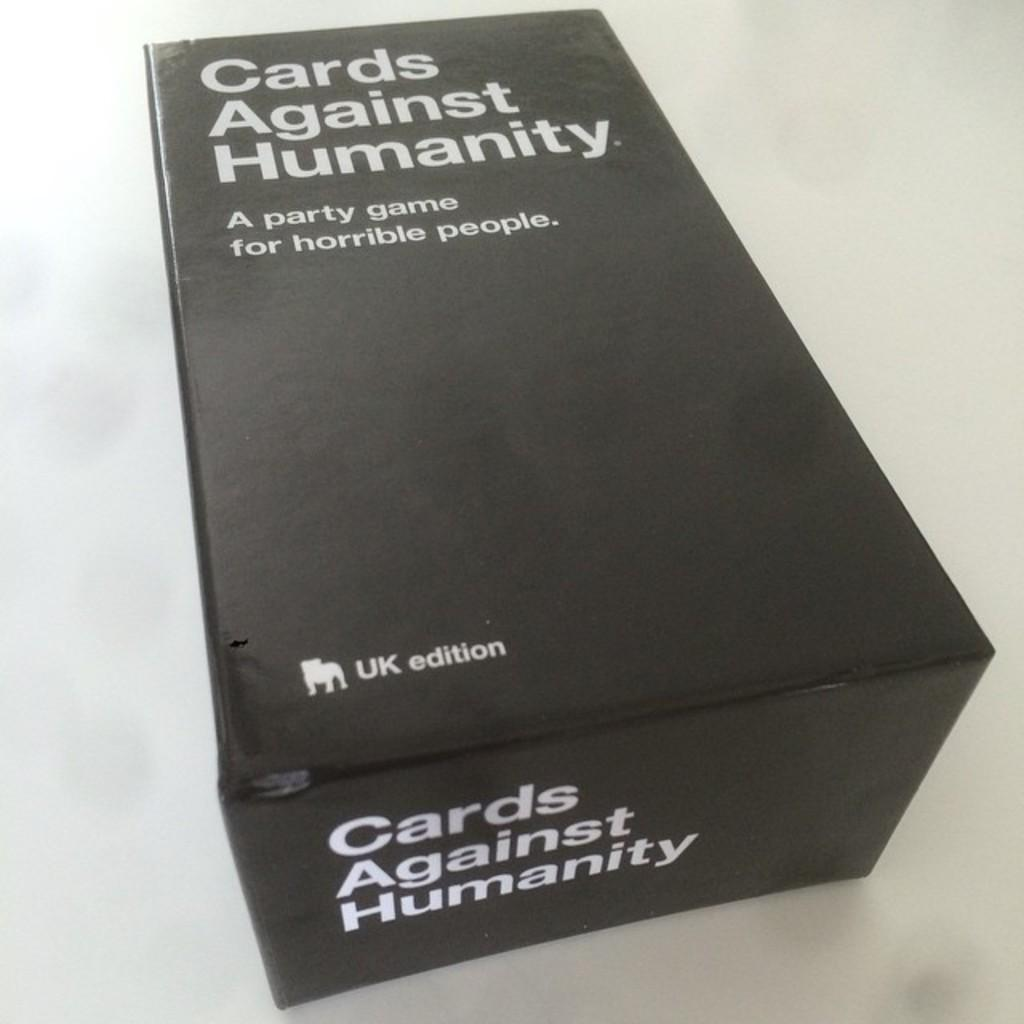<image>
Describe the image concisely. The UK edition of Cards Agains Humanity lays on a table. 